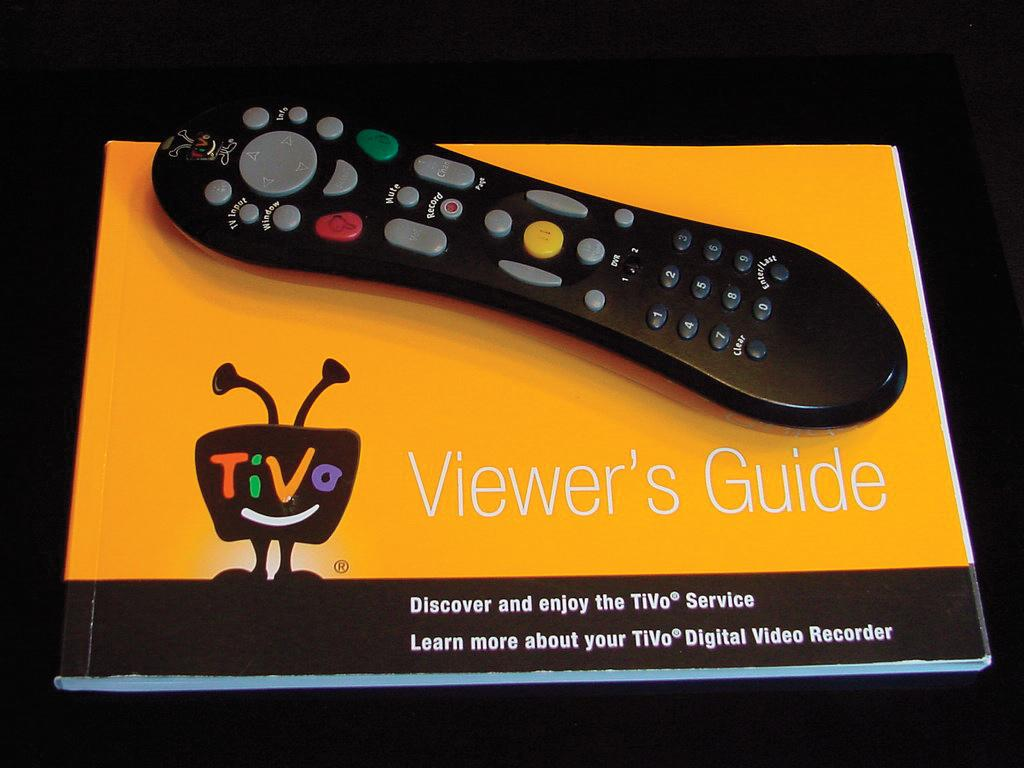<image>
Share a concise interpretation of the image provided. A black remote control on a yellow Viewer's guide 